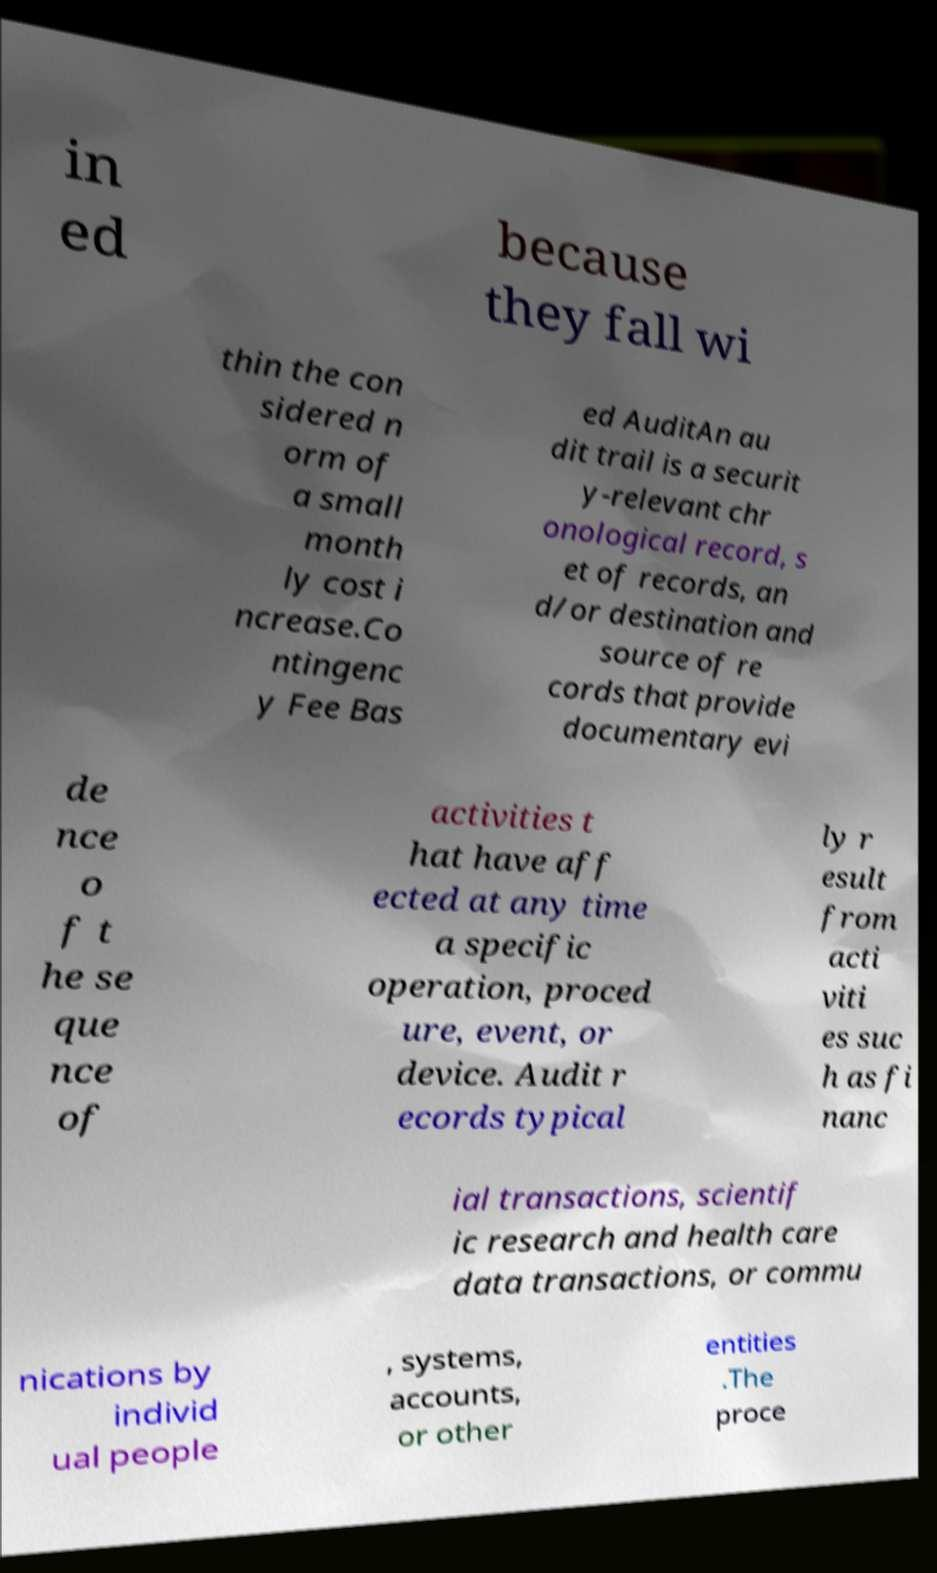I need the written content from this picture converted into text. Can you do that? in ed because they fall wi thin the con sidered n orm of a small month ly cost i ncrease.Co ntingenc y Fee Bas ed AuditAn au dit trail is a securit y-relevant chr onological record, s et of records, an d/or destination and source of re cords that provide documentary evi de nce o f t he se que nce of activities t hat have aff ected at any time a specific operation, proced ure, event, or device. Audit r ecords typical ly r esult from acti viti es suc h as fi nanc ial transactions, scientif ic research and health care data transactions, or commu nications by individ ual people , systems, accounts, or other entities .The proce 